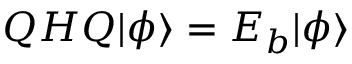<formula> <loc_0><loc_0><loc_500><loc_500>\begin{array} { r } { Q H Q | \phi \rangle = E _ { b } | \phi \rangle } \end{array}</formula> 